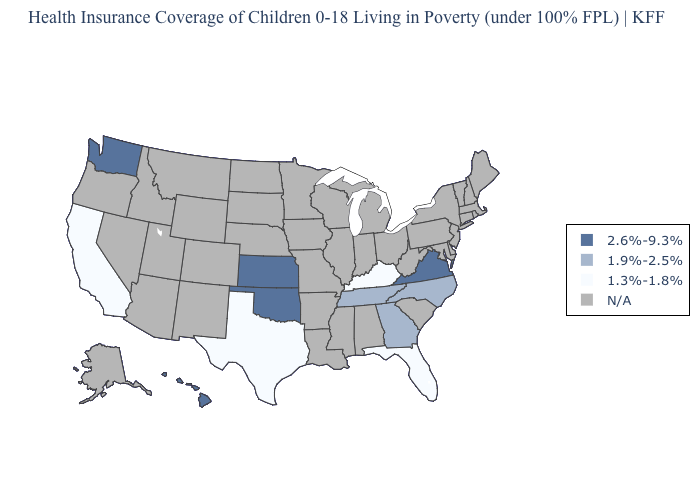Name the states that have a value in the range 2.6%-9.3%?
Answer briefly. Hawaii, Kansas, Oklahoma, Virginia, Washington. How many symbols are there in the legend?
Quick response, please. 4. What is the value of Montana?
Concise answer only. N/A. Name the states that have a value in the range N/A?
Be succinct. Alabama, Alaska, Arizona, Arkansas, Colorado, Connecticut, Delaware, Idaho, Illinois, Indiana, Iowa, Louisiana, Maine, Maryland, Massachusetts, Michigan, Minnesota, Mississippi, Missouri, Montana, Nebraska, Nevada, New Hampshire, New Jersey, New Mexico, New York, North Dakota, Ohio, Oregon, Pennsylvania, Rhode Island, South Carolina, South Dakota, Utah, Vermont, West Virginia, Wisconsin, Wyoming. Does the map have missing data?
Give a very brief answer. Yes. Which states have the lowest value in the USA?
Short answer required. California, Florida, Kentucky, Texas. What is the value of Michigan?
Answer briefly. N/A. Does the map have missing data?
Short answer required. Yes. What is the lowest value in the South?
Be succinct. 1.3%-1.8%. What is the value of North Carolina?
Short answer required. 1.9%-2.5%. Among the states that border Oklahoma , which have the highest value?
Answer briefly. Kansas. Name the states that have a value in the range 2.6%-9.3%?
Concise answer only. Hawaii, Kansas, Oklahoma, Virginia, Washington. 